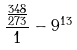<formula> <loc_0><loc_0><loc_500><loc_500>\frac { \frac { 3 4 8 } { 2 7 3 } } { 1 } - 9 ^ { 1 3 }</formula> 